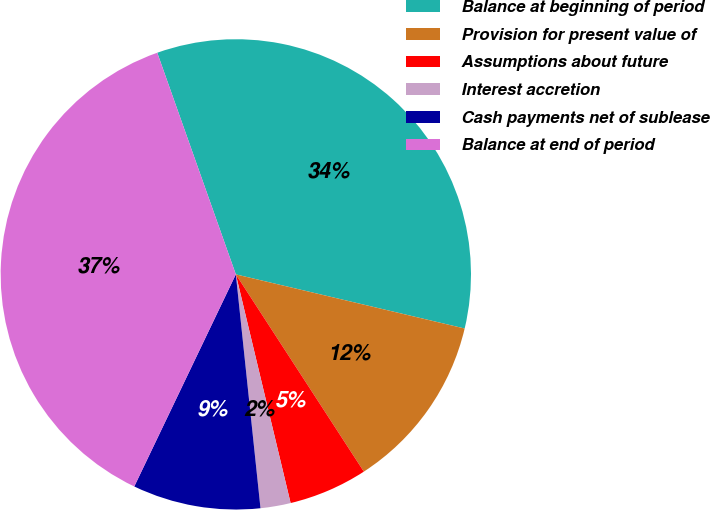Convert chart to OTSL. <chart><loc_0><loc_0><loc_500><loc_500><pie_chart><fcel>Balance at beginning of period<fcel>Provision for present value of<fcel>Assumptions about future<fcel>Interest accretion<fcel>Cash payments net of sublease<fcel>Balance at end of period<nl><fcel>34.12%<fcel>12.14%<fcel>5.42%<fcel>2.07%<fcel>8.78%<fcel>37.47%<nl></chart> 